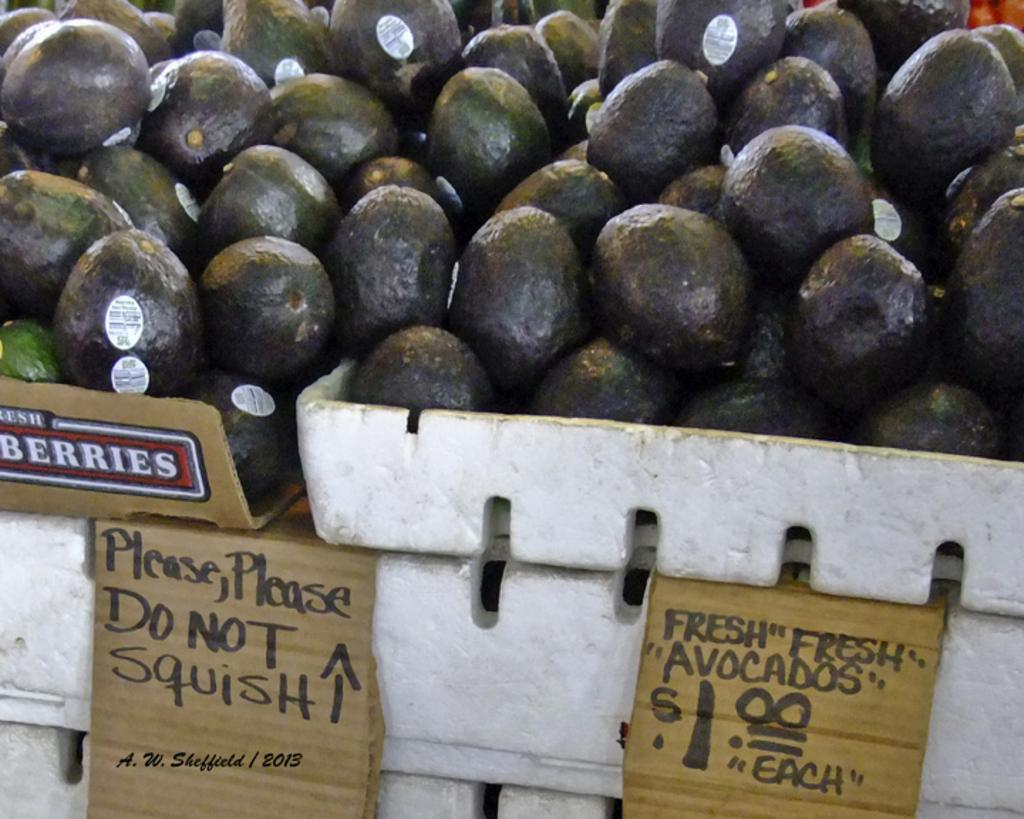What type of fruit is present in the image? There are blackberries in the image. What else can be seen in the image besides the blackberries? There are boards in the image. What is written or printed on the boards? The boards have text on them. How does the beggar interact with the blackberries in the image? There is no beggar present in the image, so it is not possible to answer that question. 